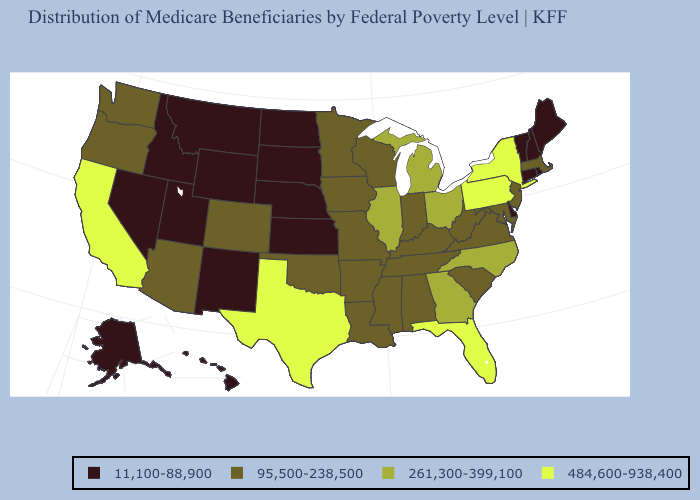Name the states that have a value in the range 11,100-88,900?
Keep it brief. Alaska, Connecticut, Delaware, Hawaii, Idaho, Kansas, Maine, Montana, Nebraska, Nevada, New Hampshire, New Mexico, North Dakota, Rhode Island, South Dakota, Utah, Vermont, Wyoming. Among the states that border Kansas , does Nebraska have the lowest value?
Be succinct. Yes. Does the map have missing data?
Give a very brief answer. No. What is the lowest value in the South?
Concise answer only. 11,100-88,900. Which states have the lowest value in the USA?
Keep it brief. Alaska, Connecticut, Delaware, Hawaii, Idaho, Kansas, Maine, Montana, Nebraska, Nevada, New Hampshire, New Mexico, North Dakota, Rhode Island, South Dakota, Utah, Vermont, Wyoming. Name the states that have a value in the range 261,300-399,100?
Concise answer only. Georgia, Illinois, Michigan, North Carolina, Ohio. Which states have the highest value in the USA?
Be succinct. California, Florida, New York, Pennsylvania, Texas. How many symbols are there in the legend?
Quick response, please. 4. How many symbols are there in the legend?
Answer briefly. 4. What is the lowest value in the West?
Give a very brief answer. 11,100-88,900. What is the value of Alabama?
Keep it brief. 95,500-238,500. Does the map have missing data?
Give a very brief answer. No. Does Arkansas have a higher value than Florida?
Keep it brief. No. Which states have the highest value in the USA?
Quick response, please. California, Florida, New York, Pennsylvania, Texas. What is the lowest value in the South?
Give a very brief answer. 11,100-88,900. 